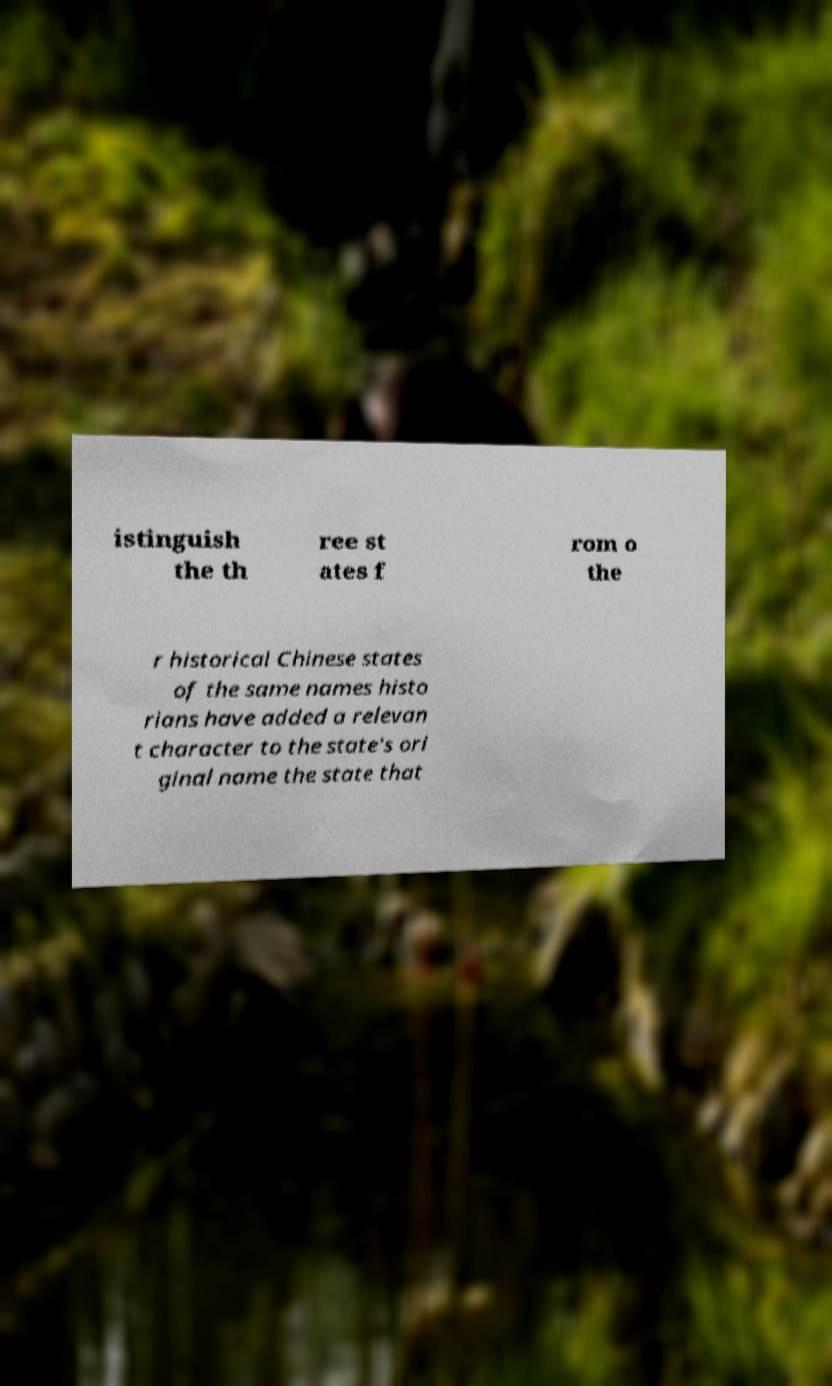Could you assist in decoding the text presented in this image and type it out clearly? istinguish the th ree st ates f rom o the r historical Chinese states of the same names histo rians have added a relevan t character to the state's ori ginal name the state that 